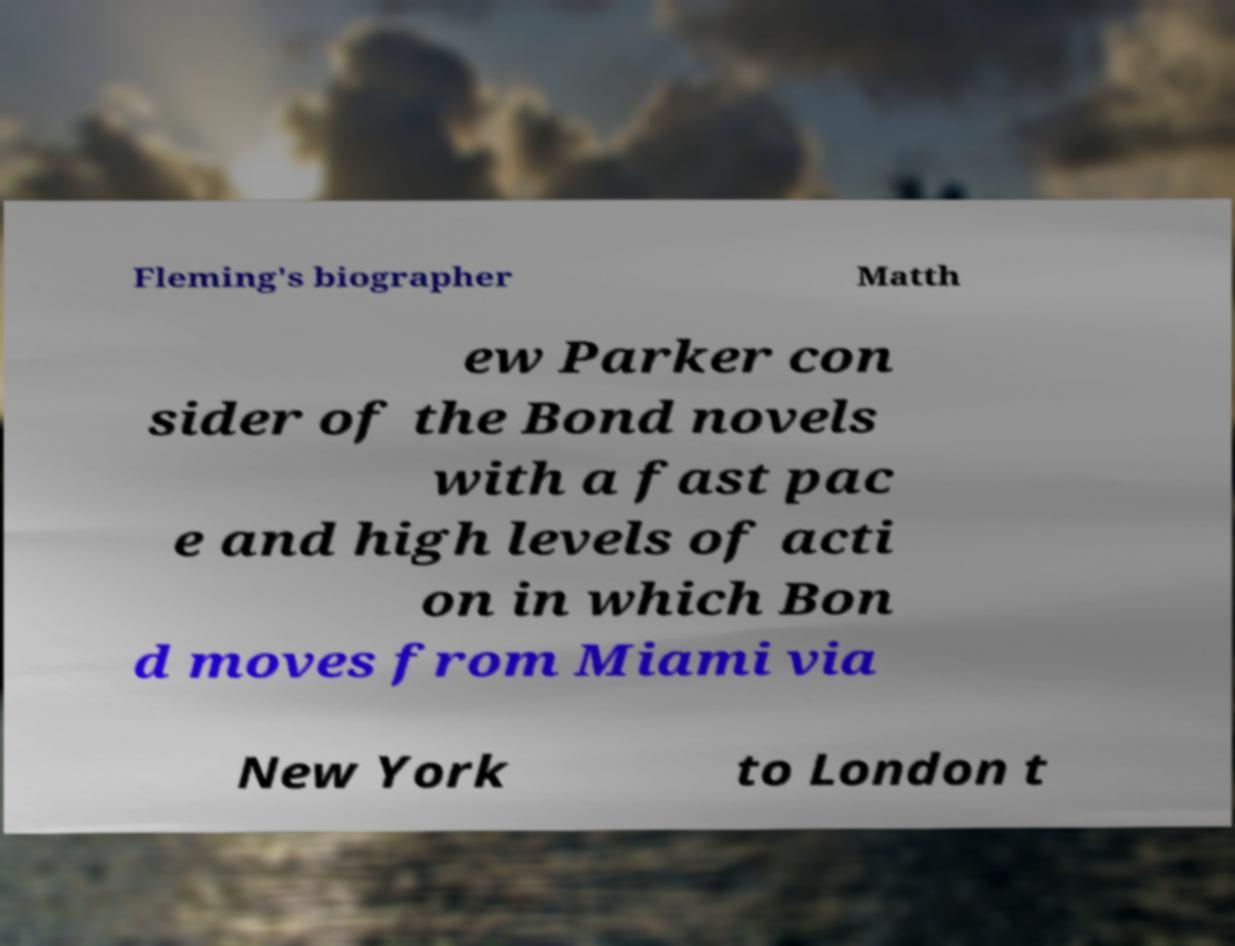There's text embedded in this image that I need extracted. Can you transcribe it verbatim? Fleming's biographer Matth ew Parker con sider of the Bond novels with a fast pac e and high levels of acti on in which Bon d moves from Miami via New York to London t 